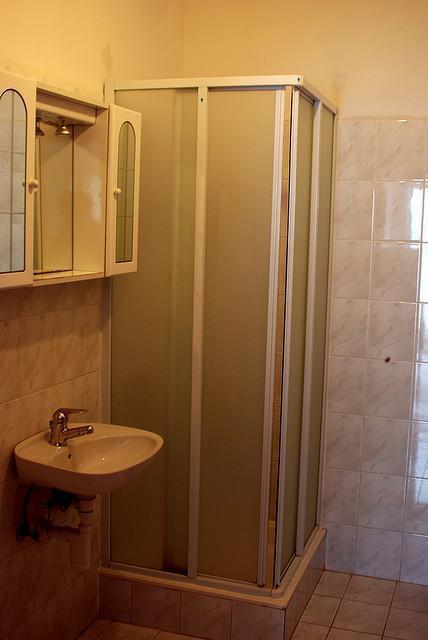How many train cars have yellow on them?
Give a very brief answer. 0. 